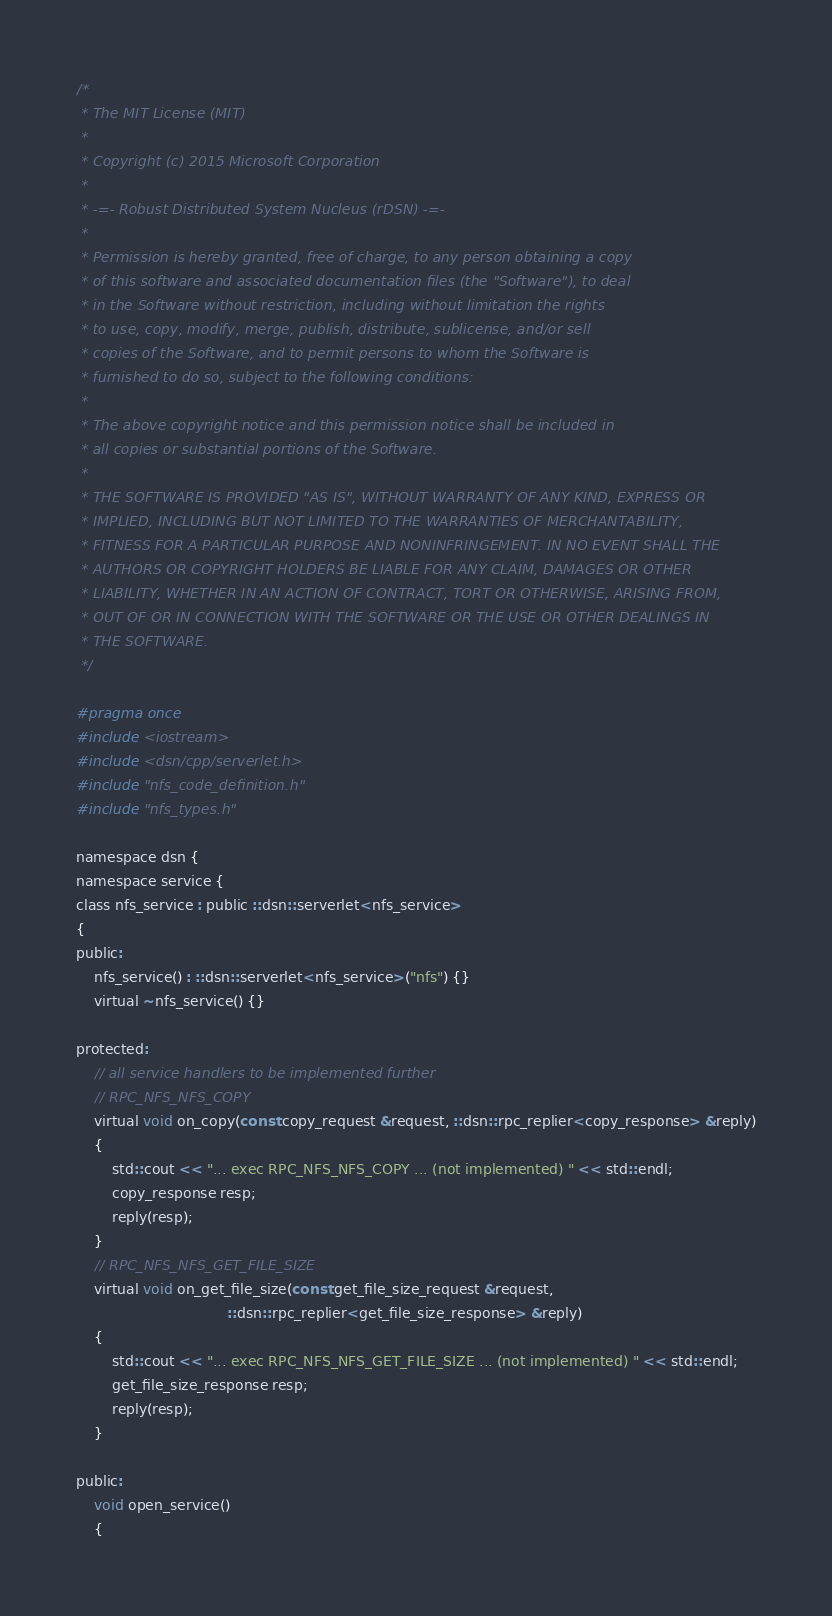Convert code to text. <code><loc_0><loc_0><loc_500><loc_500><_C_>/*
 * The MIT License (MIT)
 *
 * Copyright (c) 2015 Microsoft Corporation
 *
 * -=- Robust Distributed System Nucleus (rDSN) -=-
 *
 * Permission is hereby granted, free of charge, to any person obtaining a copy
 * of this software and associated documentation files (the "Software"), to deal
 * in the Software without restriction, including without limitation the rights
 * to use, copy, modify, merge, publish, distribute, sublicense, and/or sell
 * copies of the Software, and to permit persons to whom the Software is
 * furnished to do so, subject to the following conditions:
 *
 * The above copyright notice and this permission notice shall be included in
 * all copies or substantial portions of the Software.
 *
 * THE SOFTWARE IS PROVIDED "AS IS", WITHOUT WARRANTY OF ANY KIND, EXPRESS OR
 * IMPLIED, INCLUDING BUT NOT LIMITED TO THE WARRANTIES OF MERCHANTABILITY,
 * FITNESS FOR A PARTICULAR PURPOSE AND NONINFRINGEMENT. IN NO EVENT SHALL THE
 * AUTHORS OR COPYRIGHT HOLDERS BE LIABLE FOR ANY CLAIM, DAMAGES OR OTHER
 * LIABILITY, WHETHER IN AN ACTION OF CONTRACT, TORT OR OTHERWISE, ARISING FROM,
 * OUT OF OR IN CONNECTION WITH THE SOFTWARE OR THE USE OR OTHER DEALINGS IN
 * THE SOFTWARE.
 */

#pragma once
#include <iostream>
#include <dsn/cpp/serverlet.h>
#include "nfs_code_definition.h"
#include "nfs_types.h"

namespace dsn {
namespace service {
class nfs_service : public ::dsn::serverlet<nfs_service>
{
public:
    nfs_service() : ::dsn::serverlet<nfs_service>("nfs") {}
    virtual ~nfs_service() {}

protected:
    // all service handlers to be implemented further
    // RPC_NFS_NFS_COPY
    virtual void on_copy(const copy_request &request, ::dsn::rpc_replier<copy_response> &reply)
    {
        std::cout << "... exec RPC_NFS_NFS_COPY ... (not implemented) " << std::endl;
        copy_response resp;
        reply(resp);
    }
    // RPC_NFS_NFS_GET_FILE_SIZE
    virtual void on_get_file_size(const get_file_size_request &request,
                                  ::dsn::rpc_replier<get_file_size_response> &reply)
    {
        std::cout << "... exec RPC_NFS_NFS_GET_FILE_SIZE ... (not implemented) " << std::endl;
        get_file_size_response resp;
        reply(resp);
    }

public:
    void open_service()
    {</code> 